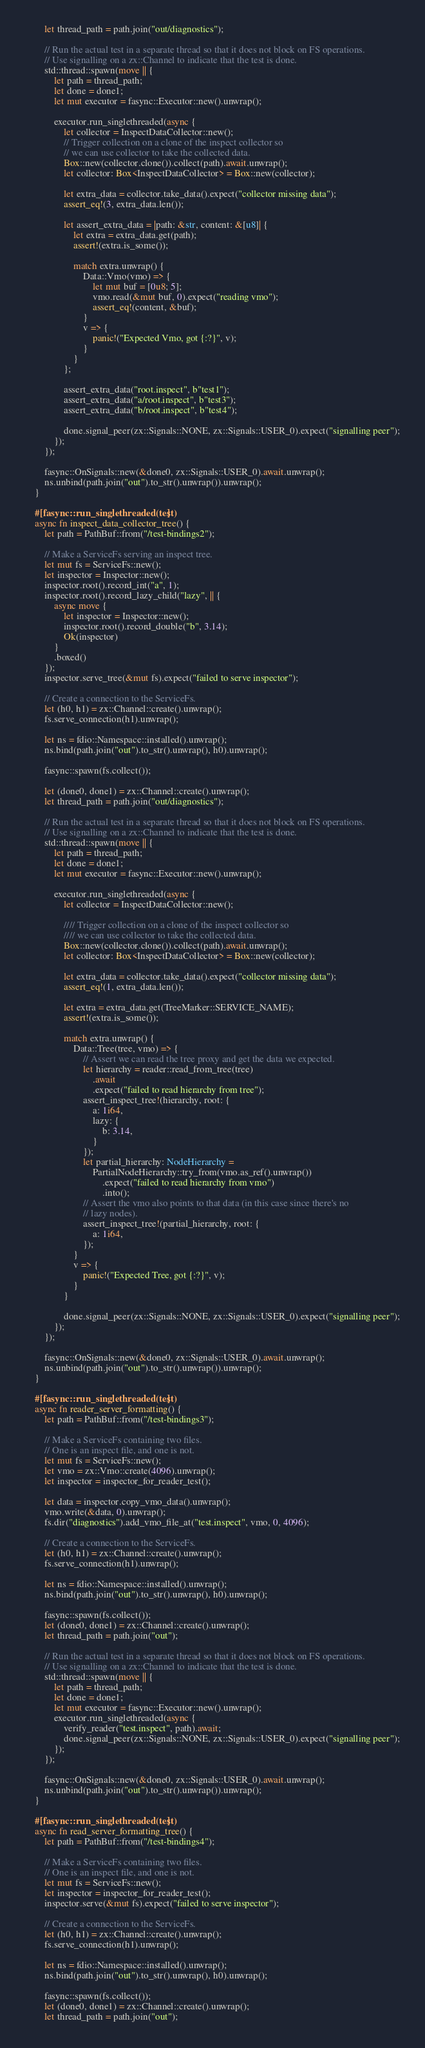Convert code to text. <code><loc_0><loc_0><loc_500><loc_500><_Rust_>
        let thread_path = path.join("out/diagnostics");

        // Run the actual test in a separate thread so that it does not block on FS operations.
        // Use signalling on a zx::Channel to indicate that the test is done.
        std::thread::spawn(move || {
            let path = thread_path;
            let done = done1;
            let mut executor = fasync::Executor::new().unwrap();

            executor.run_singlethreaded(async {
                let collector = InspectDataCollector::new();
                // Trigger collection on a clone of the inspect collector so
                // we can use collector to take the collected data.
                Box::new(collector.clone()).collect(path).await.unwrap();
                let collector: Box<InspectDataCollector> = Box::new(collector);

                let extra_data = collector.take_data().expect("collector missing data");
                assert_eq!(3, extra_data.len());

                let assert_extra_data = |path: &str, content: &[u8]| {
                    let extra = extra_data.get(path);
                    assert!(extra.is_some());

                    match extra.unwrap() {
                        Data::Vmo(vmo) => {
                            let mut buf = [0u8; 5];
                            vmo.read(&mut buf, 0).expect("reading vmo");
                            assert_eq!(content, &buf);
                        }
                        v => {
                            panic!("Expected Vmo, got {:?}", v);
                        }
                    }
                };

                assert_extra_data("root.inspect", b"test1");
                assert_extra_data("a/root.inspect", b"test3");
                assert_extra_data("b/root.inspect", b"test4");

                done.signal_peer(zx::Signals::NONE, zx::Signals::USER_0).expect("signalling peer");
            });
        });

        fasync::OnSignals::new(&done0, zx::Signals::USER_0).await.unwrap();
        ns.unbind(path.join("out").to_str().unwrap()).unwrap();
    }

    #[fasync::run_singlethreaded(test)]
    async fn inspect_data_collector_tree() {
        let path = PathBuf::from("/test-bindings2");

        // Make a ServiceFs serving an inspect tree.
        let mut fs = ServiceFs::new();
        let inspector = Inspector::new();
        inspector.root().record_int("a", 1);
        inspector.root().record_lazy_child("lazy", || {
            async move {
                let inspector = Inspector::new();
                inspector.root().record_double("b", 3.14);
                Ok(inspector)
            }
            .boxed()
        });
        inspector.serve_tree(&mut fs).expect("failed to serve inspector");

        // Create a connection to the ServiceFs.
        let (h0, h1) = zx::Channel::create().unwrap();
        fs.serve_connection(h1).unwrap();

        let ns = fdio::Namespace::installed().unwrap();
        ns.bind(path.join("out").to_str().unwrap(), h0).unwrap();

        fasync::spawn(fs.collect());

        let (done0, done1) = zx::Channel::create().unwrap();
        let thread_path = path.join("out/diagnostics");

        // Run the actual test in a separate thread so that it does not block on FS operations.
        // Use signalling on a zx::Channel to indicate that the test is done.
        std::thread::spawn(move || {
            let path = thread_path;
            let done = done1;
            let mut executor = fasync::Executor::new().unwrap();

            executor.run_singlethreaded(async {
                let collector = InspectDataCollector::new();

                //// Trigger collection on a clone of the inspect collector so
                //// we can use collector to take the collected data.
                Box::new(collector.clone()).collect(path).await.unwrap();
                let collector: Box<InspectDataCollector> = Box::new(collector);

                let extra_data = collector.take_data().expect("collector missing data");
                assert_eq!(1, extra_data.len());

                let extra = extra_data.get(TreeMarker::SERVICE_NAME);
                assert!(extra.is_some());

                match extra.unwrap() {
                    Data::Tree(tree, vmo) => {
                        // Assert we can read the tree proxy and get the data we expected.
                        let hierarchy = reader::read_from_tree(tree)
                            .await
                            .expect("failed to read hierarchy from tree");
                        assert_inspect_tree!(hierarchy, root: {
                            a: 1i64,
                            lazy: {
                                b: 3.14,
                            }
                        });
                        let partial_hierarchy: NodeHierarchy =
                            PartialNodeHierarchy::try_from(vmo.as_ref().unwrap())
                                .expect("failed to read hierarchy from vmo")
                                .into();
                        // Assert the vmo also points to that data (in this case since there's no
                        // lazy nodes).
                        assert_inspect_tree!(partial_hierarchy, root: {
                            a: 1i64,
                        });
                    }
                    v => {
                        panic!("Expected Tree, got {:?}", v);
                    }
                }

                done.signal_peer(zx::Signals::NONE, zx::Signals::USER_0).expect("signalling peer");
            });
        });

        fasync::OnSignals::new(&done0, zx::Signals::USER_0).await.unwrap();
        ns.unbind(path.join("out").to_str().unwrap()).unwrap();
    }

    #[fasync::run_singlethreaded(test)]
    async fn reader_server_formatting() {
        let path = PathBuf::from("/test-bindings3");

        // Make a ServiceFs containing two files.
        // One is an inspect file, and one is not.
        let mut fs = ServiceFs::new();
        let vmo = zx::Vmo::create(4096).unwrap();
        let inspector = inspector_for_reader_test();

        let data = inspector.copy_vmo_data().unwrap();
        vmo.write(&data, 0).unwrap();
        fs.dir("diagnostics").add_vmo_file_at("test.inspect", vmo, 0, 4096);

        // Create a connection to the ServiceFs.
        let (h0, h1) = zx::Channel::create().unwrap();
        fs.serve_connection(h1).unwrap();

        let ns = fdio::Namespace::installed().unwrap();
        ns.bind(path.join("out").to_str().unwrap(), h0).unwrap();

        fasync::spawn(fs.collect());
        let (done0, done1) = zx::Channel::create().unwrap();
        let thread_path = path.join("out");

        // Run the actual test in a separate thread so that it does not block on FS operations.
        // Use signalling on a zx::Channel to indicate that the test is done.
        std::thread::spawn(move || {
            let path = thread_path;
            let done = done1;
            let mut executor = fasync::Executor::new().unwrap();
            executor.run_singlethreaded(async {
                verify_reader("test.inspect", path).await;
                done.signal_peer(zx::Signals::NONE, zx::Signals::USER_0).expect("signalling peer");
            });
        });

        fasync::OnSignals::new(&done0, zx::Signals::USER_0).await.unwrap();
        ns.unbind(path.join("out").to_str().unwrap()).unwrap();
    }

    #[fasync::run_singlethreaded(test)]
    async fn read_server_formatting_tree() {
        let path = PathBuf::from("/test-bindings4");

        // Make a ServiceFs containing two files.
        // One is an inspect file, and one is not.
        let mut fs = ServiceFs::new();
        let inspector = inspector_for_reader_test();
        inspector.serve(&mut fs).expect("failed to serve inspector");

        // Create a connection to the ServiceFs.
        let (h0, h1) = zx::Channel::create().unwrap();
        fs.serve_connection(h1).unwrap();

        let ns = fdio::Namespace::installed().unwrap();
        ns.bind(path.join("out").to_str().unwrap(), h0).unwrap();

        fasync::spawn(fs.collect());
        let (done0, done1) = zx::Channel::create().unwrap();
        let thread_path = path.join("out");
</code> 